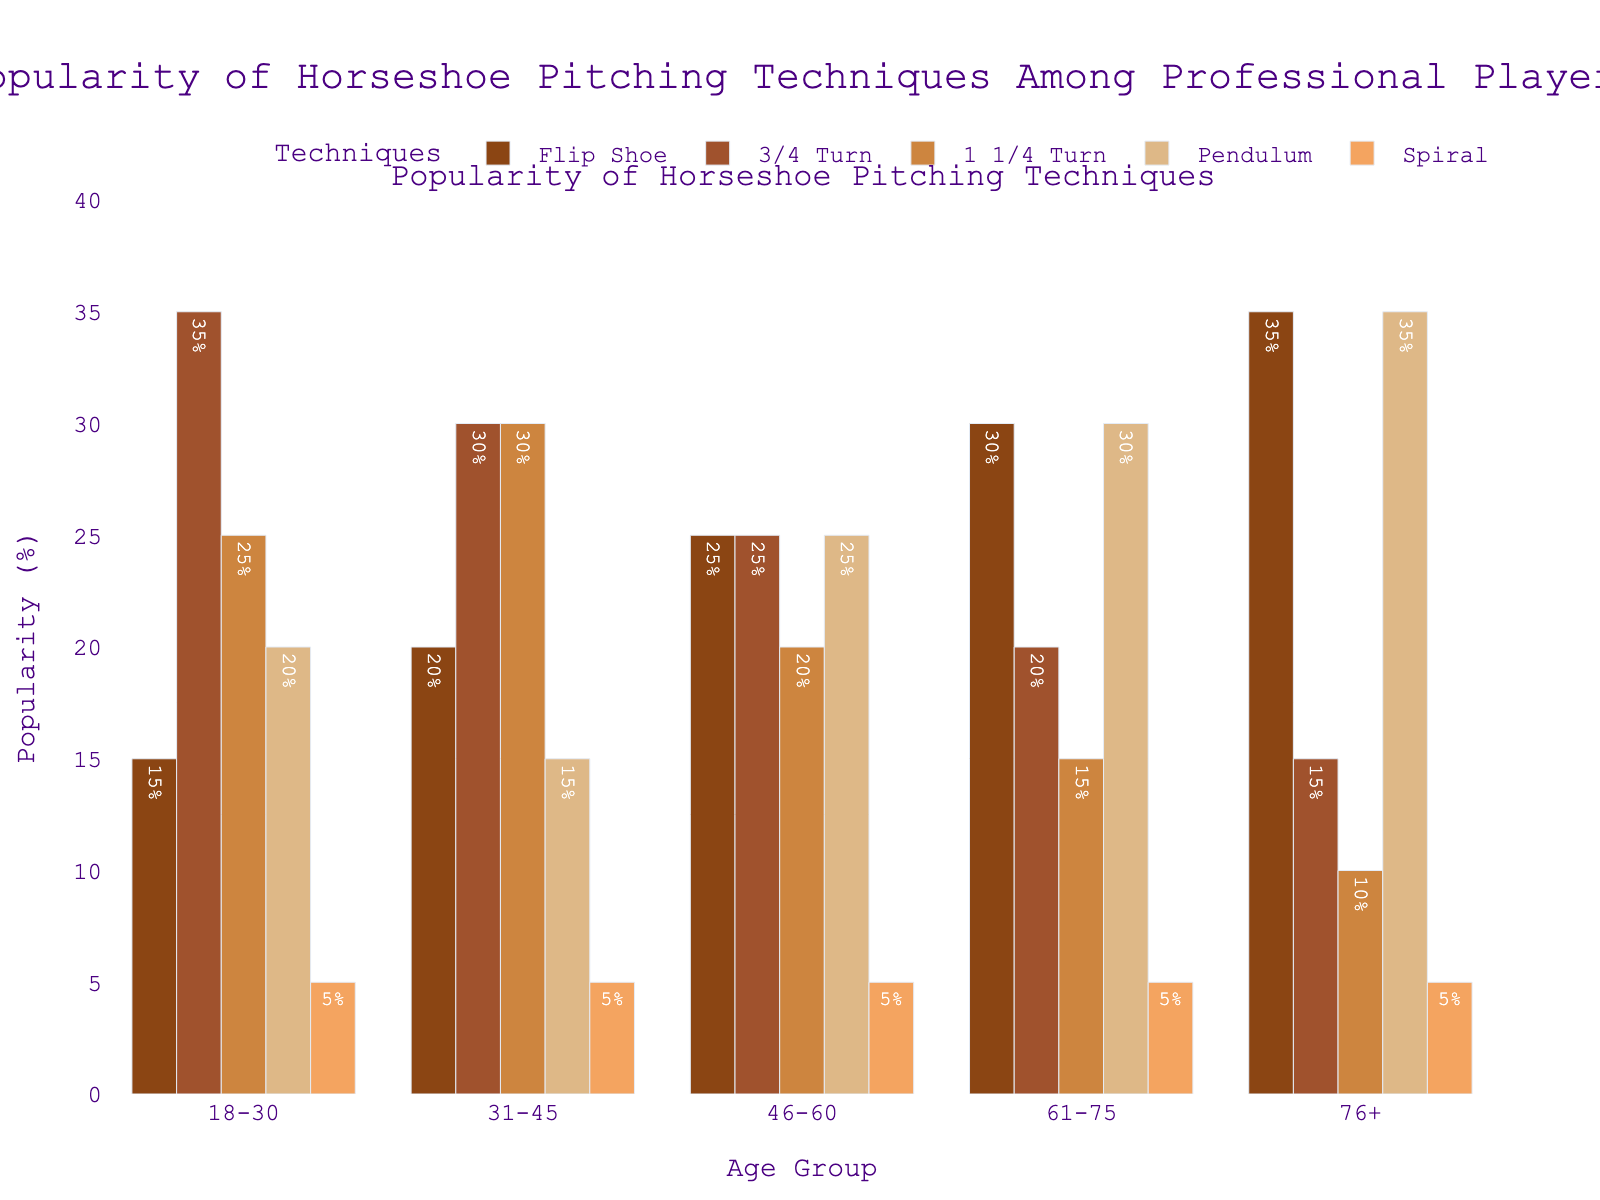Which age group has the highest popularity for the Flip Shoe technique? The Flip Shoe technique is most popular among the age group with the highest percentage bar for this technique. Upon examining the chart, the 76+ age group has the tallest bar for the Flip Shoe, which is 35%.
Answer: 76+ Between the 46-60 and 61-75 age groups, which one prefers the 3/4 Turn technique more? To determine the preference for the 3/4 Turn technique between the 46-60 and 61-75 age groups, compare the heights of the 3/4 Turn bars for these groups. The 3/4 Turn is 25% for 46-60, higher than the 20% for 61-75.
Answer: 46-60 What is the average popularity of the Pendulum technique across all age groups? To find the average popularity, add the Pendulum percentages for all age groups and divide by the number of groups: (20% + 15% + 25% + 30% + 35%) / 5 = 25%.
Answer: 25% Which technique has consistent popularity of 5% across all age groups? Examine the bars of each technique to find one where the percentage is the same across all age groups. The Spiral technique has a consistent 5% across all groups.
Answer: Spiral Compare the combined popularity of Flip Shoe and 1 1/4 Turn techniques for the 31-45 age group with the combined popularity of these techniques for the 76+ age group. Which is higher and by how much? Calculate the combined popularity for Flip Shoe and 1 1/4 Turn for both groups: 31-45 (20% + 30% = 50%), 76+ (35% + 10% = 45%). The difference is 50% - 45% = 5%.
Answer: 31-45; 5% How does the popularity of the Pendulum technique change as age increases? Observe the trend of the Pendulum technique's bars across age groups. The percentages are 20%, 15%, 25%, 30%, and 35%, showing an increasing trend as age increases.
Answer: Increases Which age group shows the least interest in the 3/4 Turn technique, and what is its popularity percentage? The bar representing the 3/4 Turn technique for each age group must be compared. The smallest bar is for the 76+ age group with a 15% popularity.
Answer: 76+; 15% Is there any age group where the Flip Shoe technique is the least popular? Compare the height of the Flip Shoe bar within each age group to the other techniques in the same group. In no age group is Flip Shoe the least popular; its least popularity (15%) is still not the lowest in the 18-30 group.
Answer: No What is the sum of the percentages for all techniques for the 61-75 age group? Add the percentages of each technique for the 61-75 age group: 30% (Flip Shoe) + 20% (3/4 Turn) + 15% (1 1/4 Turn) + 30% (Pendulum) + 5% (Spiral) = 100%.
Answer: 100% 